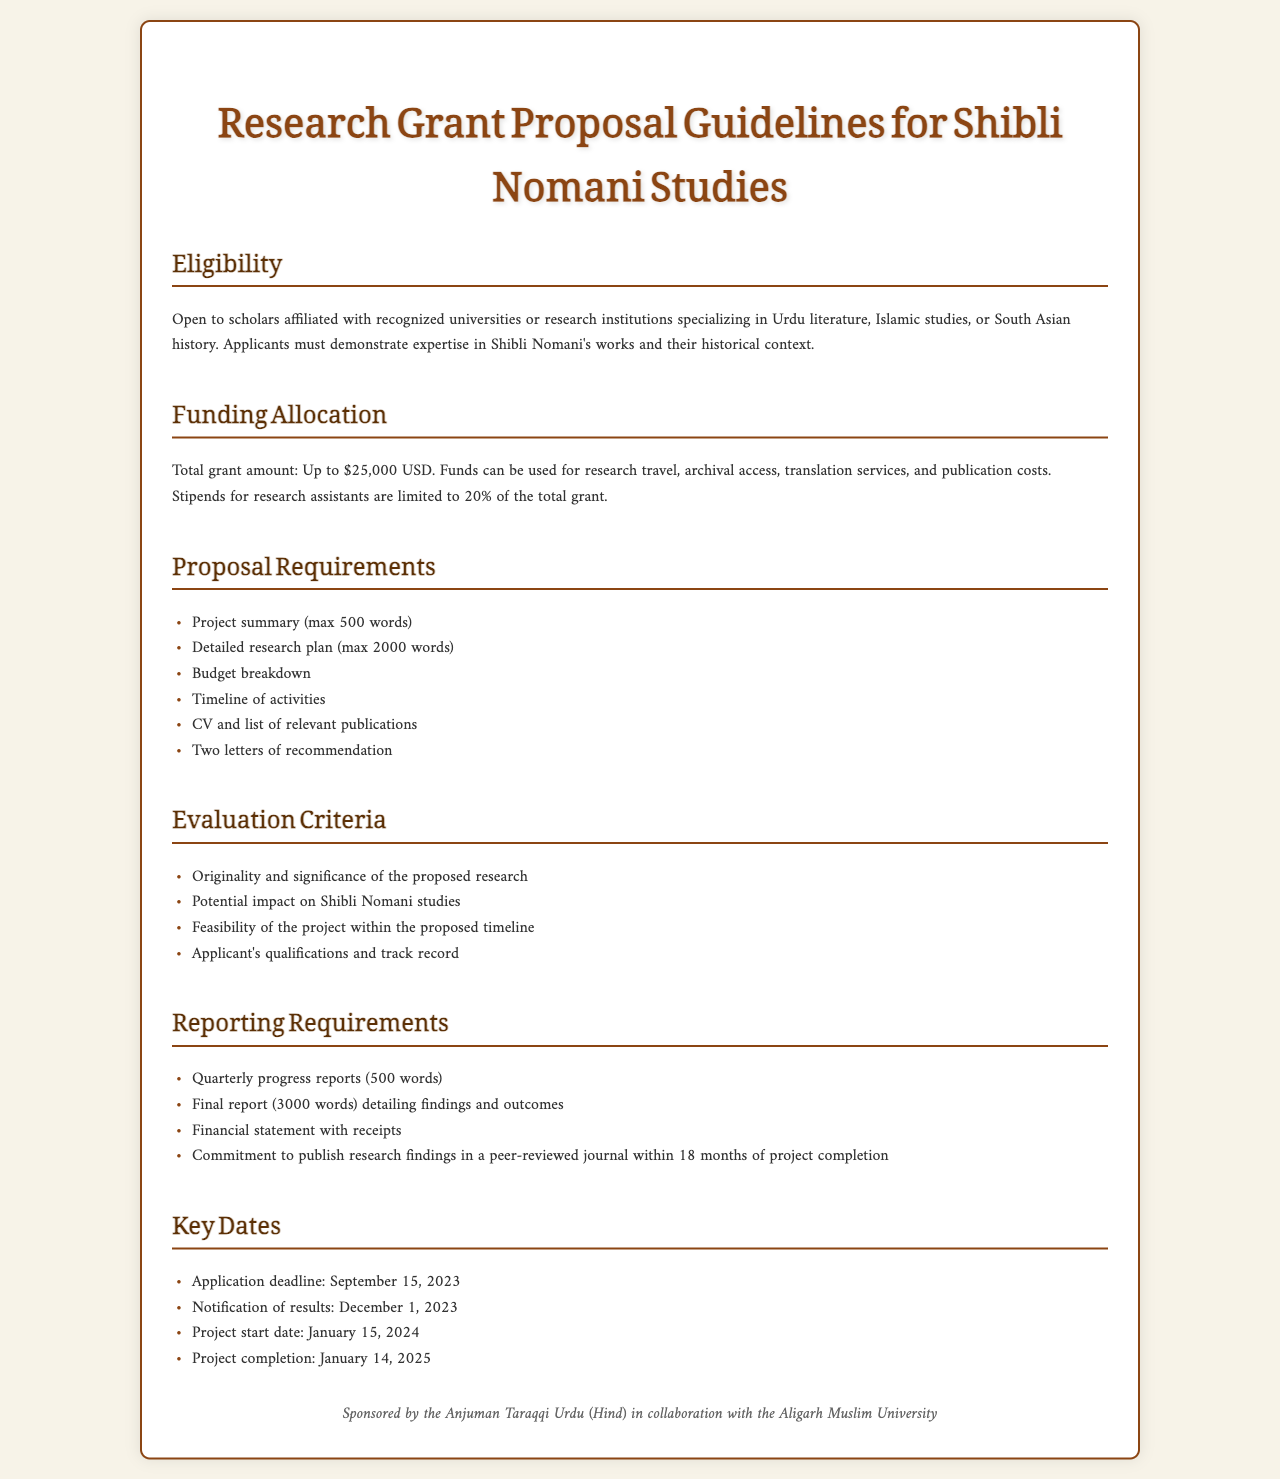What is the total grant amount available? The document states the total grant amount is specified for the research.
Answer: Up to $25,000 USD Who is eligible to apply for the grant? The document describes the eligibility criteria for applicants.
Answer: Scholars affiliated with recognized universities or research institutions What is the deadline for applications? The document mentions a specific date for the application deadline.
Answer: September 15, 2023 How many letters of recommendation are required? The proposal requirements list the number of recommendation letters needed.
Answer: Two letters of recommendation What percentage of the grant can be allocated for research assistants' stipends? The funding allocation section specifies a limit for stipends.
Answer: 20% of the total grant What is the final report's length requirement? The reporting requirements detail the word count for the final report.
Answer: 3000 words What is the project completion date? The key dates section includes the project's completion date.
Answer: January 14, 2025 What is required for the financial statement? The reporting requirements outline what must be included in the financial statement.
Answer: Receipts 